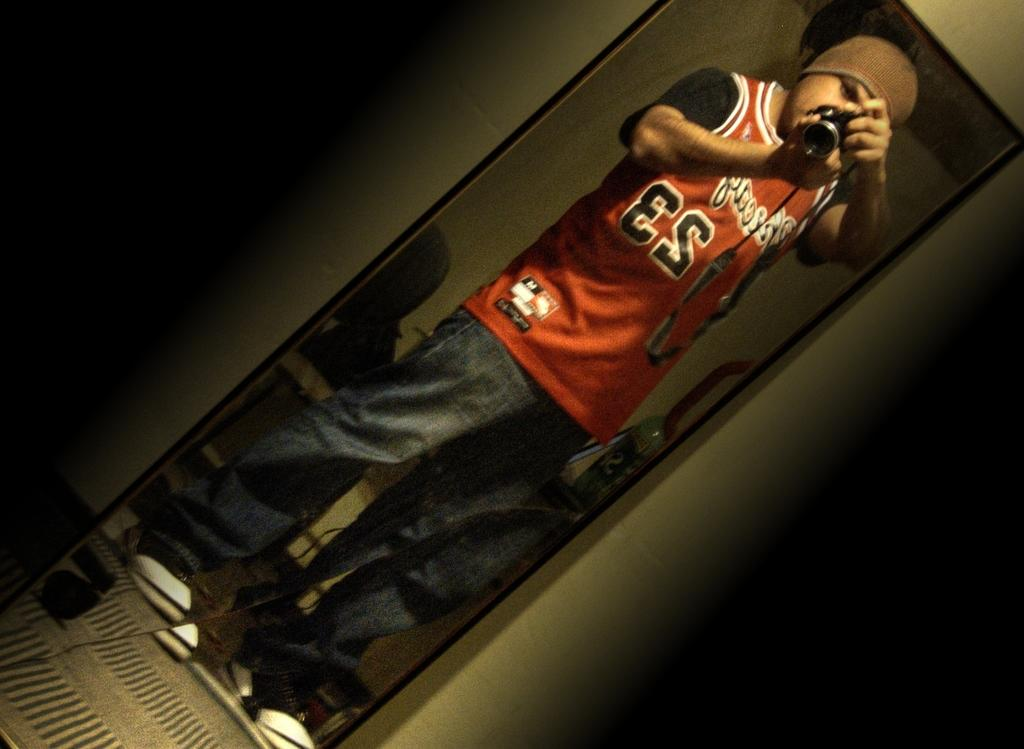<image>
Describe the image concisely. A man in a red number 23 jersey takes a selfie. 